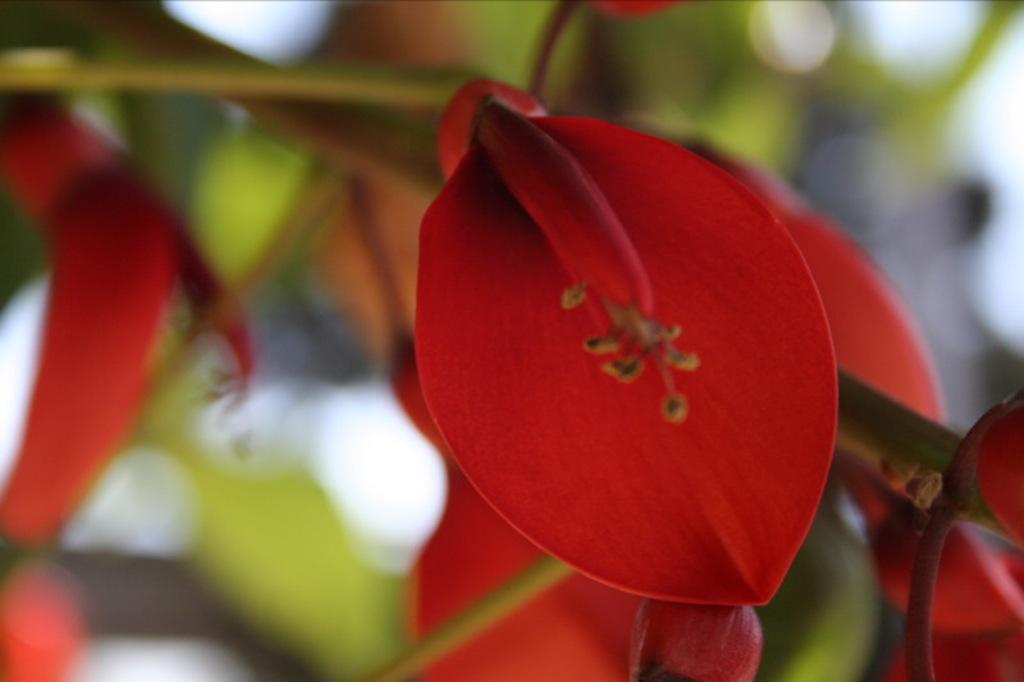What color are the petals on the leaf in the image? The petals on the leaf in the image are red. Can you describe the background of the image? The background of the image is blurry. What type of cheese is being discussed in the image? There is no discussion or cheese present in the image; it features red petals on a leaf with a blurry background. 